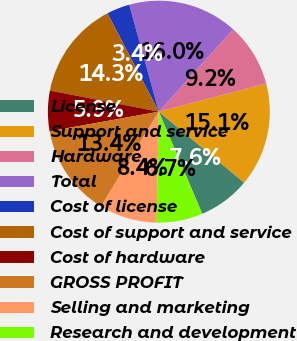Convert chart to OTSL. <chart><loc_0><loc_0><loc_500><loc_500><pie_chart><fcel>License<fcel>Support and service<fcel>Hardware<fcel>Total<fcel>Cost of license<fcel>Cost of support and service<fcel>Cost of hardware<fcel>GROSS PROFIT<fcel>Selling and marketing<fcel>Research and development<nl><fcel>7.56%<fcel>15.13%<fcel>9.24%<fcel>15.97%<fcel>3.36%<fcel>14.29%<fcel>5.88%<fcel>13.45%<fcel>8.4%<fcel>6.72%<nl></chart> 